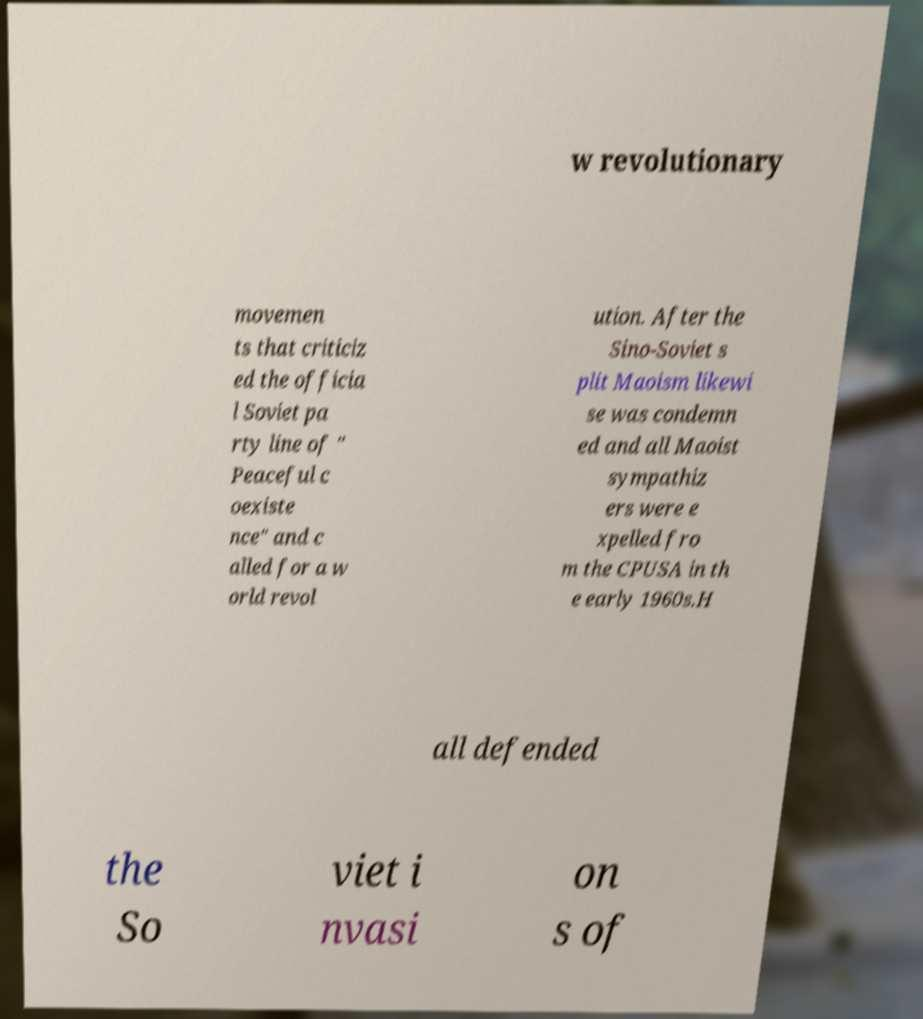Could you assist in decoding the text presented in this image and type it out clearly? w revolutionary movemen ts that criticiz ed the officia l Soviet pa rty line of " Peaceful c oexiste nce" and c alled for a w orld revol ution. After the Sino-Soviet s plit Maoism likewi se was condemn ed and all Maoist sympathiz ers were e xpelled fro m the CPUSA in th e early 1960s.H all defended the So viet i nvasi on s of 